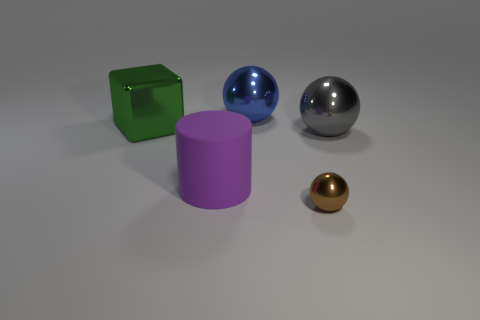Subtract all gray spheres. How many spheres are left? 2 Add 5 small green matte blocks. How many objects exist? 10 Subtract 2 spheres. How many spheres are left? 1 Subtract all blue balls. How many balls are left? 2 Subtract all balls. How many objects are left? 2 Add 5 cylinders. How many cylinders are left? 6 Add 2 large blue metal things. How many large blue metal things exist? 3 Subtract 0 brown cubes. How many objects are left? 5 Subtract all green spheres. Subtract all blue cylinders. How many spheres are left? 3 Subtract all tiny metal objects. Subtract all purple cylinders. How many objects are left? 3 